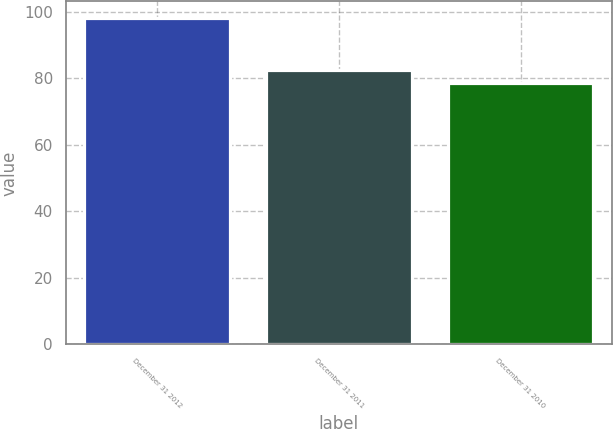Convert chart to OTSL. <chart><loc_0><loc_0><loc_500><loc_500><bar_chart><fcel>December 31 2012<fcel>December 31 2011<fcel>December 31 2010<nl><fcel>98.2<fcel>82.4<fcel>78.7<nl></chart> 